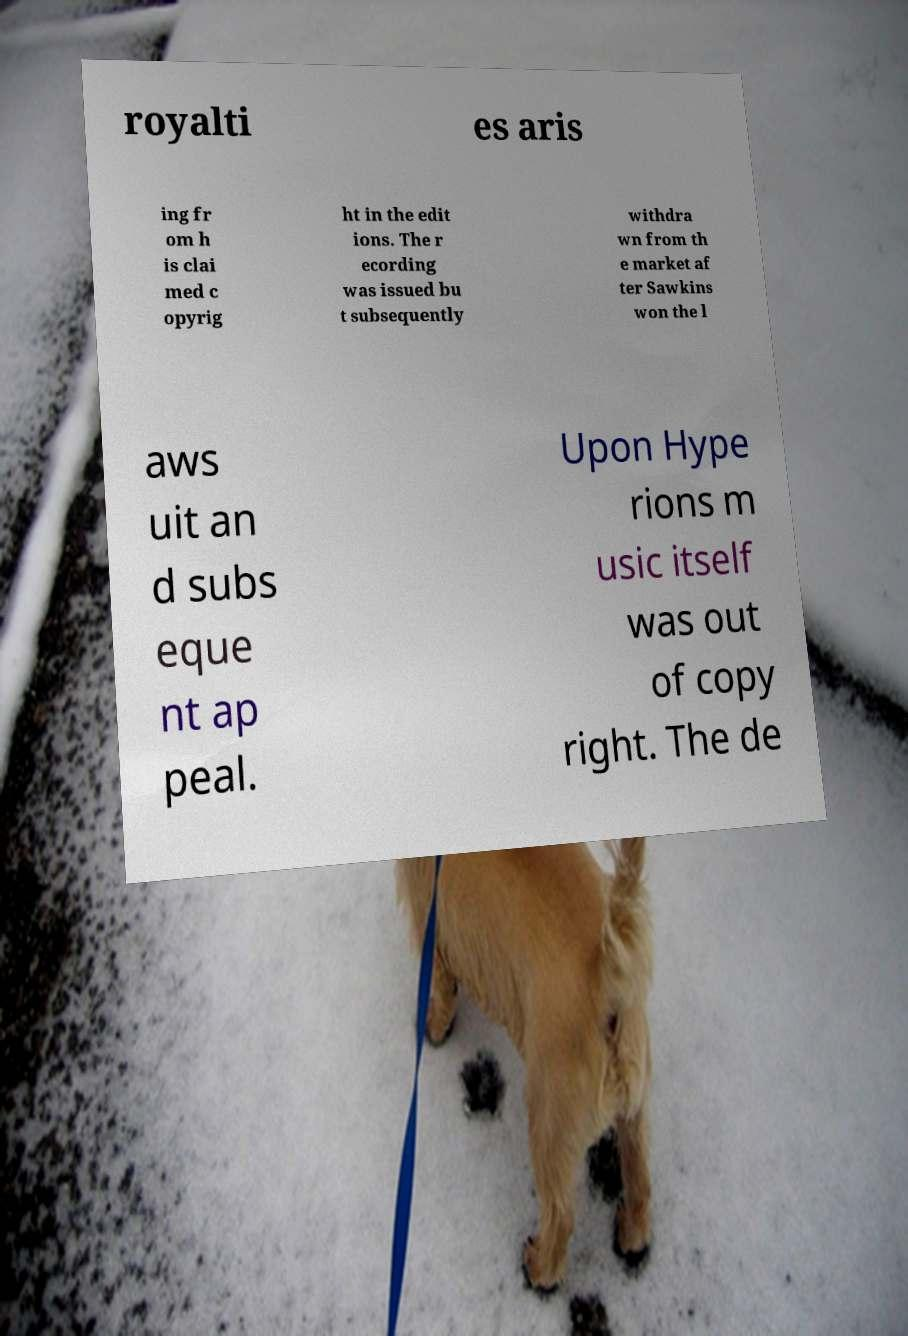Please read and relay the text visible in this image. What does it say? royalti es aris ing fr om h is clai med c opyrig ht in the edit ions. The r ecording was issued bu t subsequently withdra wn from th e market af ter Sawkins won the l aws uit an d subs eque nt ap peal. Upon Hype rions m usic itself was out of copy right. The de 